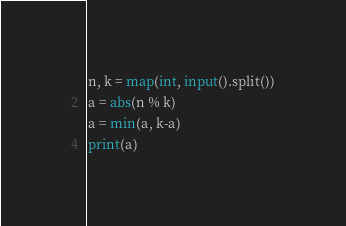Convert code to text. <code><loc_0><loc_0><loc_500><loc_500><_Python_>n, k = map(int, input().split())
a = abs(n % k)
a = min(a, k-a)
print(a)
</code> 